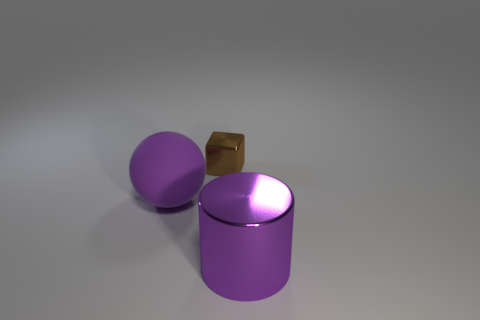Are there any other things that have the same material as the large purple sphere?
Offer a very short reply. No. What is the color of the big object that is in front of the purple object to the left of the small brown cube?
Provide a short and direct response. Purple. Does the large cylinder have the same color as the big rubber object?
Offer a very short reply. Yes. There is a thing behind the thing left of the brown metallic thing; what is it made of?
Your response must be concise. Metal. Are there any purple objects in front of the large purple thing that is to the left of the metal object in front of the big matte object?
Make the answer very short. Yes. What number of other objects are there of the same color as the tiny block?
Keep it short and to the point. 0. What number of things are both in front of the tiny metal block and right of the big purple rubber sphere?
Offer a very short reply. 1. What is the shape of the purple metal thing?
Ensure brevity in your answer.  Cylinder. What number of other things are made of the same material as the purple cylinder?
Your response must be concise. 1. There is a thing that is left of the shiny thing left of the thing to the right of the cube; what color is it?
Provide a short and direct response. Purple. 